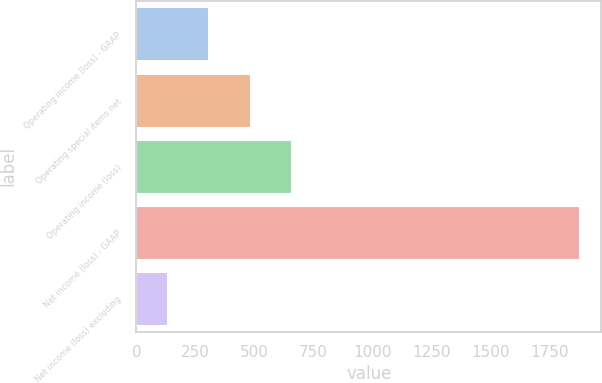<chart> <loc_0><loc_0><loc_500><loc_500><bar_chart><fcel>Operating income (loss) - GAAP<fcel>Operating special items net<fcel>Operating income (loss)<fcel>Net income (loss) - GAAP<fcel>Net income (loss) excluding<nl><fcel>304.6<fcel>479.2<fcel>653.8<fcel>1876<fcel>130<nl></chart> 